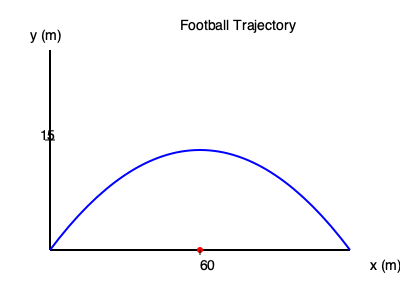As a defensive coach, you're analyzing a kicker's punt trajectory. The path of the football can be modeled by the quadratic equation $y = -\frac{1}{240}x^2 + \frac{1}{4}x$, where $x$ and $y$ are measured in meters. What is the maximum height reached by the football during its flight? To find the maximum height of the football's trajectory, we need to follow these steps:

1) The quadratic equation is in the form $y = ax^2 + bx + c$, where:
   $a = -\frac{1}{240}$, $b = \frac{1}{4}$, and $c = 0$

2) For a quadratic function, the x-coordinate of the vertex represents the point where the maximum height is reached. We can find this using the formula: $x = -\frac{b}{2a}$

3) Let's calculate $x$:
   $x = -\frac{\frac{1}{4}}{2(-\frac{1}{240})} = -\frac{1}{4} \cdot -\frac{480}{2} = 60$ meters

4) Now that we know the x-coordinate of the vertex, we can find the maximum height by plugging this x-value back into our original equation:

   $y = -\frac{1}{240}(60)^2 + \frac{1}{4}(60)$
   
   $= -\frac{3600}{240} + 15$
   
   $= -15 + 15 = 15$ meters

Therefore, the maximum height reached by the football is 15 meters.
Answer: 15 meters 